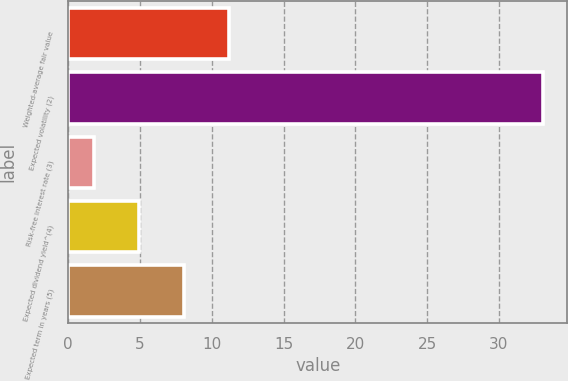Convert chart. <chart><loc_0><loc_0><loc_500><loc_500><bar_chart><fcel>Weighted-average fair value<fcel>Expected volatility (2)<fcel>Risk-free interest rate (3)<fcel>Expected dividend yield^(4)<fcel>Expected term in years (5)<nl><fcel>11.19<fcel>33.1<fcel>1.8<fcel>4.93<fcel>8.06<nl></chart> 